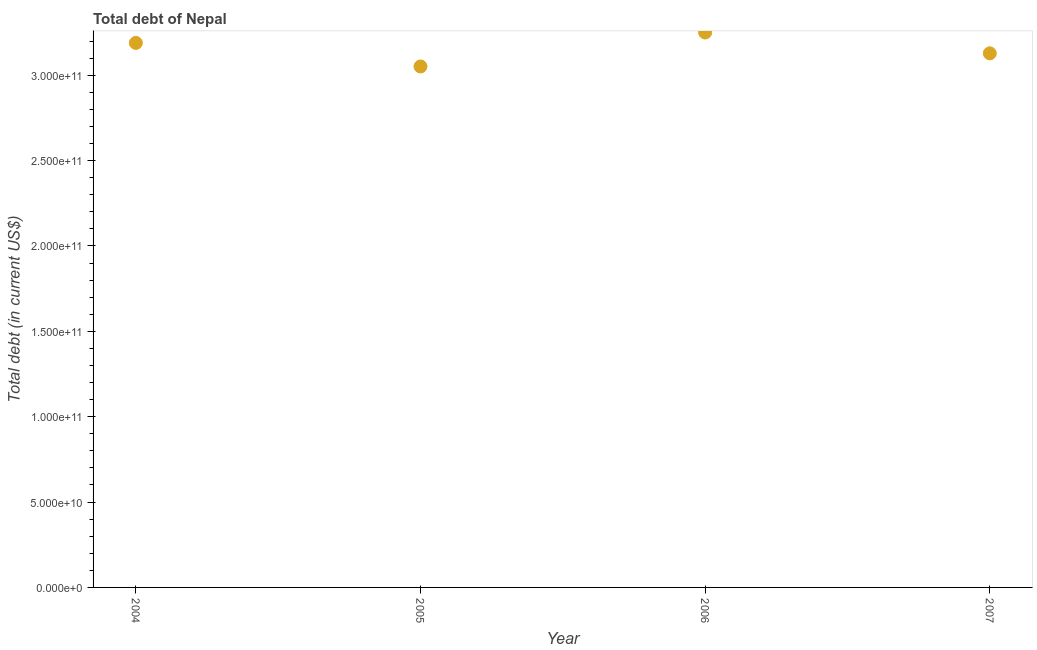What is the total debt in 2007?
Ensure brevity in your answer.  3.13e+11. Across all years, what is the maximum total debt?
Give a very brief answer. 3.25e+11. Across all years, what is the minimum total debt?
Ensure brevity in your answer.  3.05e+11. In which year was the total debt minimum?
Your response must be concise. 2005. What is the sum of the total debt?
Your answer should be compact. 1.26e+12. What is the difference between the total debt in 2004 and 2006?
Keep it short and to the point. -6.08e+09. What is the average total debt per year?
Provide a short and direct response. 3.15e+11. What is the median total debt?
Your answer should be compact. 3.16e+11. What is the ratio of the total debt in 2004 to that in 2007?
Your response must be concise. 1.02. What is the difference between the highest and the second highest total debt?
Your answer should be compact. 6.08e+09. What is the difference between the highest and the lowest total debt?
Give a very brief answer. 1.99e+1. Does the total debt monotonically increase over the years?
Your answer should be very brief. No. What is the difference between two consecutive major ticks on the Y-axis?
Offer a terse response. 5.00e+1. Are the values on the major ticks of Y-axis written in scientific E-notation?
Offer a terse response. Yes. Does the graph contain grids?
Provide a short and direct response. No. What is the title of the graph?
Offer a terse response. Total debt of Nepal. What is the label or title of the Y-axis?
Provide a short and direct response. Total debt (in current US$). What is the Total debt (in current US$) in 2004?
Your response must be concise. 3.19e+11. What is the Total debt (in current US$) in 2005?
Ensure brevity in your answer.  3.05e+11. What is the Total debt (in current US$) in 2006?
Offer a terse response. 3.25e+11. What is the Total debt (in current US$) in 2007?
Your answer should be very brief. 3.13e+11. What is the difference between the Total debt (in current US$) in 2004 and 2005?
Offer a terse response. 1.38e+1. What is the difference between the Total debt (in current US$) in 2004 and 2006?
Your answer should be very brief. -6.08e+09. What is the difference between the Total debt (in current US$) in 2004 and 2007?
Offer a very short reply. 6.10e+09. What is the difference between the Total debt (in current US$) in 2005 and 2006?
Keep it short and to the point. -1.99e+1. What is the difference between the Total debt (in current US$) in 2005 and 2007?
Offer a very short reply. -7.70e+09. What is the difference between the Total debt (in current US$) in 2006 and 2007?
Offer a very short reply. 1.22e+1. What is the ratio of the Total debt (in current US$) in 2004 to that in 2005?
Your answer should be very brief. 1.04. What is the ratio of the Total debt (in current US$) in 2004 to that in 2006?
Your answer should be compact. 0.98. What is the ratio of the Total debt (in current US$) in 2004 to that in 2007?
Give a very brief answer. 1.02. What is the ratio of the Total debt (in current US$) in 2005 to that in 2006?
Make the answer very short. 0.94. What is the ratio of the Total debt (in current US$) in 2005 to that in 2007?
Offer a very short reply. 0.97. What is the ratio of the Total debt (in current US$) in 2006 to that in 2007?
Keep it short and to the point. 1.04. 